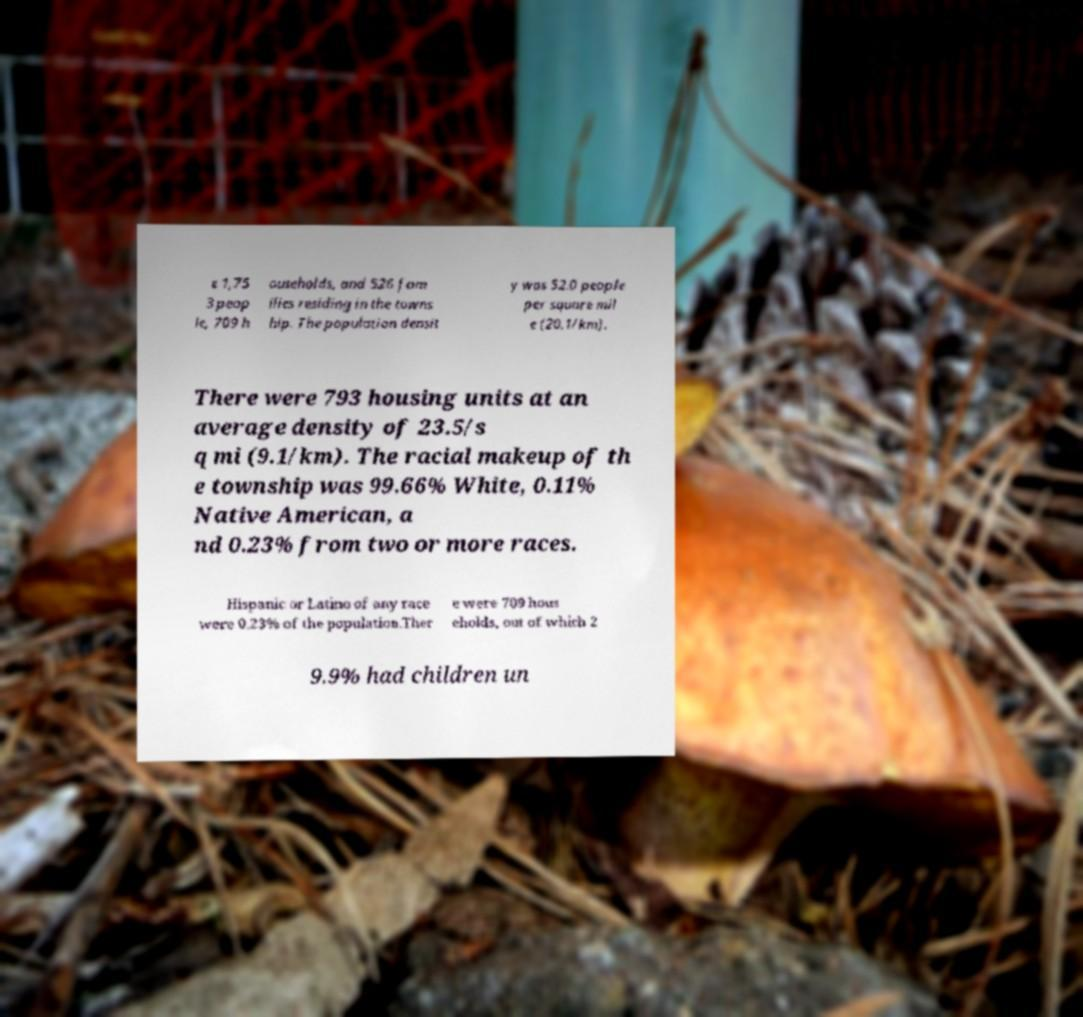There's text embedded in this image that I need extracted. Can you transcribe it verbatim? e 1,75 3 peop le, 709 h ouseholds, and 526 fam ilies residing in the towns hip. The population densit y was 52.0 people per square mil e (20.1/km). There were 793 housing units at an average density of 23.5/s q mi (9.1/km). The racial makeup of th e township was 99.66% White, 0.11% Native American, a nd 0.23% from two or more races. Hispanic or Latino of any race were 0.23% of the population.Ther e were 709 hous eholds, out of which 2 9.9% had children un 